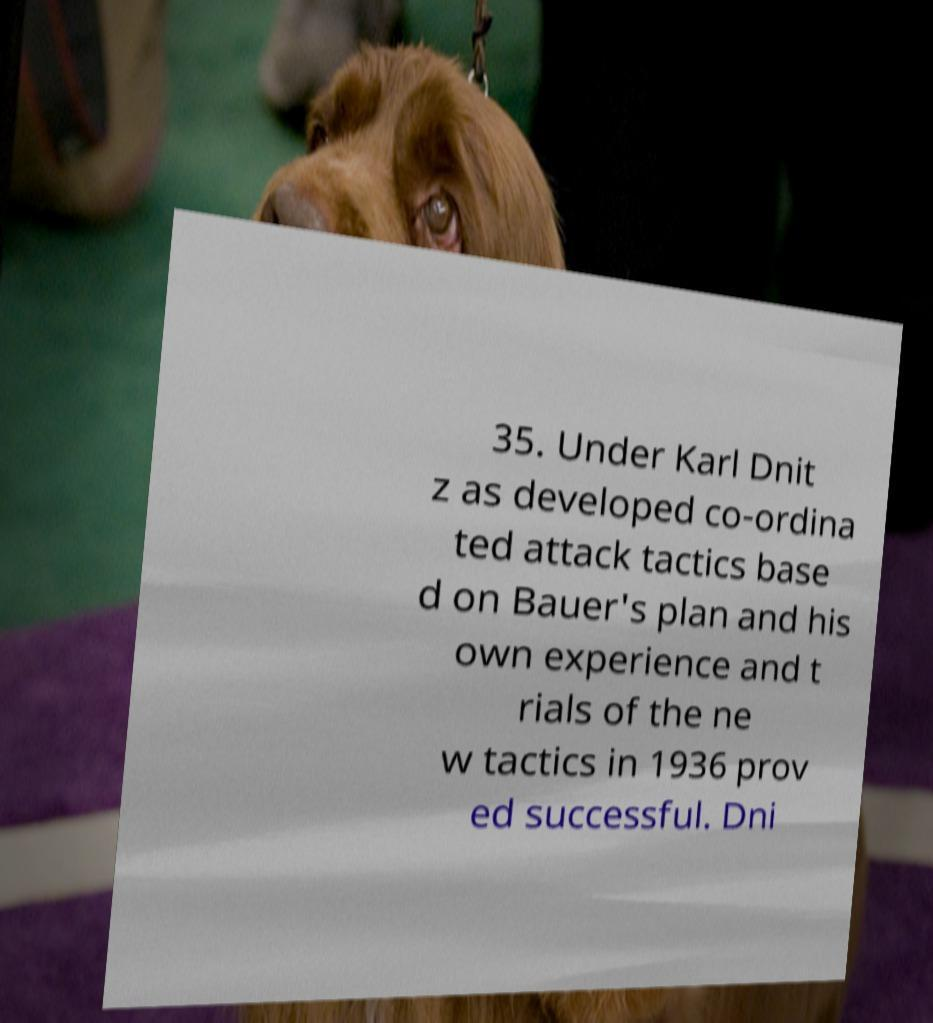Can you accurately transcribe the text from the provided image for me? 35. Under Karl Dnit z as developed co-ordina ted attack tactics base d on Bauer's plan and his own experience and t rials of the ne w tactics in 1936 prov ed successful. Dni 